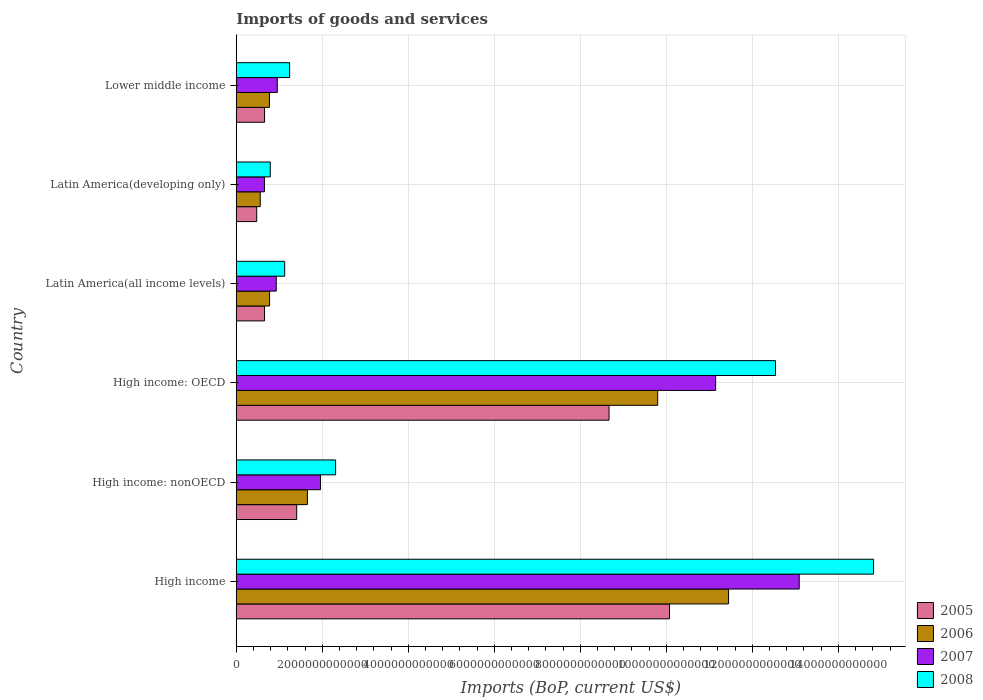How many different coloured bars are there?
Provide a succinct answer. 4. How many groups of bars are there?
Give a very brief answer. 6. What is the label of the 1st group of bars from the top?
Offer a terse response. Lower middle income. In how many cases, is the number of bars for a given country not equal to the number of legend labels?
Offer a terse response. 0. What is the amount spent on imports in 2005 in Lower middle income?
Your response must be concise. 6.58e+11. Across all countries, what is the maximum amount spent on imports in 2007?
Keep it short and to the point. 1.31e+13. Across all countries, what is the minimum amount spent on imports in 2006?
Make the answer very short. 5.57e+11. In which country was the amount spent on imports in 2005 minimum?
Offer a terse response. Latin America(developing only). What is the total amount spent on imports in 2008 in the graph?
Make the answer very short. 3.28e+13. What is the difference between the amount spent on imports in 2005 in High income: nonOECD and that in Lower middle income?
Your answer should be very brief. 7.47e+11. What is the difference between the amount spent on imports in 2005 in Latin America(all income levels) and the amount spent on imports in 2006 in Latin America(developing only)?
Keep it short and to the point. 9.99e+1. What is the average amount spent on imports in 2007 per country?
Give a very brief answer. 4.79e+12. What is the difference between the amount spent on imports in 2007 and amount spent on imports in 2008 in Latin America(all income levels)?
Keep it short and to the point. -1.96e+11. What is the ratio of the amount spent on imports in 2007 in High income: OECD to that in Latin America(developing only)?
Your response must be concise. 17.01. Is the amount spent on imports in 2007 in High income: OECD less than that in High income: nonOECD?
Your answer should be very brief. No. Is the difference between the amount spent on imports in 2007 in High income: nonOECD and Latin America(all income levels) greater than the difference between the amount spent on imports in 2008 in High income: nonOECD and Latin America(all income levels)?
Provide a succinct answer. No. What is the difference between the highest and the second highest amount spent on imports in 2007?
Offer a very short reply. 1.94e+12. What is the difference between the highest and the lowest amount spent on imports in 2006?
Give a very brief answer. 1.09e+13. In how many countries, is the amount spent on imports in 2007 greater than the average amount spent on imports in 2007 taken over all countries?
Give a very brief answer. 2. Is it the case that in every country, the sum of the amount spent on imports in 2006 and amount spent on imports in 2008 is greater than the sum of amount spent on imports in 2007 and amount spent on imports in 2005?
Give a very brief answer. No. What does the 3rd bar from the bottom in Latin America(developing only) represents?
Make the answer very short. 2007. What is the difference between two consecutive major ticks on the X-axis?
Your answer should be compact. 2.00e+12. Does the graph contain any zero values?
Provide a short and direct response. No. Where does the legend appear in the graph?
Ensure brevity in your answer.  Bottom right. How are the legend labels stacked?
Ensure brevity in your answer.  Vertical. What is the title of the graph?
Your response must be concise. Imports of goods and services. Does "1970" appear as one of the legend labels in the graph?
Your response must be concise. No. What is the label or title of the X-axis?
Ensure brevity in your answer.  Imports (BoP, current US$). What is the Imports (BoP, current US$) of 2005 in High income?
Offer a terse response. 1.01e+13. What is the Imports (BoP, current US$) of 2006 in High income?
Give a very brief answer. 1.14e+13. What is the Imports (BoP, current US$) in 2007 in High income?
Provide a succinct answer. 1.31e+13. What is the Imports (BoP, current US$) in 2008 in High income?
Your response must be concise. 1.48e+13. What is the Imports (BoP, current US$) of 2005 in High income: nonOECD?
Ensure brevity in your answer.  1.41e+12. What is the Imports (BoP, current US$) in 2006 in High income: nonOECD?
Give a very brief answer. 1.65e+12. What is the Imports (BoP, current US$) in 2007 in High income: nonOECD?
Ensure brevity in your answer.  1.96e+12. What is the Imports (BoP, current US$) in 2008 in High income: nonOECD?
Your answer should be compact. 2.31e+12. What is the Imports (BoP, current US$) in 2005 in High income: OECD?
Keep it short and to the point. 8.67e+12. What is the Imports (BoP, current US$) in 2006 in High income: OECD?
Ensure brevity in your answer.  9.80e+12. What is the Imports (BoP, current US$) of 2007 in High income: OECD?
Your response must be concise. 1.11e+13. What is the Imports (BoP, current US$) in 2008 in High income: OECD?
Your response must be concise. 1.25e+13. What is the Imports (BoP, current US$) in 2005 in Latin America(all income levels)?
Ensure brevity in your answer.  6.57e+11. What is the Imports (BoP, current US$) in 2006 in Latin America(all income levels)?
Ensure brevity in your answer.  7.75e+11. What is the Imports (BoP, current US$) in 2007 in Latin America(all income levels)?
Keep it short and to the point. 9.30e+11. What is the Imports (BoP, current US$) in 2008 in Latin America(all income levels)?
Provide a succinct answer. 1.13e+12. What is the Imports (BoP, current US$) of 2005 in Latin America(developing only)?
Your answer should be very brief. 4.75e+11. What is the Imports (BoP, current US$) in 2006 in Latin America(developing only)?
Offer a very short reply. 5.57e+11. What is the Imports (BoP, current US$) in 2007 in Latin America(developing only)?
Your answer should be very brief. 6.55e+11. What is the Imports (BoP, current US$) of 2008 in Latin America(developing only)?
Ensure brevity in your answer.  7.91e+11. What is the Imports (BoP, current US$) in 2005 in Lower middle income?
Give a very brief answer. 6.58e+11. What is the Imports (BoP, current US$) in 2006 in Lower middle income?
Provide a succinct answer. 7.71e+11. What is the Imports (BoP, current US$) in 2007 in Lower middle income?
Your answer should be very brief. 9.53e+11. What is the Imports (BoP, current US$) in 2008 in Lower middle income?
Give a very brief answer. 1.24e+12. Across all countries, what is the maximum Imports (BoP, current US$) of 2005?
Your answer should be compact. 1.01e+13. Across all countries, what is the maximum Imports (BoP, current US$) of 2006?
Your answer should be compact. 1.14e+13. Across all countries, what is the maximum Imports (BoP, current US$) of 2007?
Offer a very short reply. 1.31e+13. Across all countries, what is the maximum Imports (BoP, current US$) in 2008?
Provide a succinct answer. 1.48e+13. Across all countries, what is the minimum Imports (BoP, current US$) of 2005?
Offer a very short reply. 4.75e+11. Across all countries, what is the minimum Imports (BoP, current US$) of 2006?
Offer a terse response. 5.57e+11. Across all countries, what is the minimum Imports (BoP, current US$) in 2007?
Ensure brevity in your answer.  6.55e+11. Across all countries, what is the minimum Imports (BoP, current US$) of 2008?
Offer a terse response. 7.91e+11. What is the total Imports (BoP, current US$) in 2005 in the graph?
Your answer should be very brief. 2.19e+13. What is the total Imports (BoP, current US$) of 2006 in the graph?
Make the answer very short. 2.50e+13. What is the total Imports (BoP, current US$) in 2007 in the graph?
Offer a very short reply. 2.87e+13. What is the total Imports (BoP, current US$) in 2008 in the graph?
Your answer should be very brief. 3.28e+13. What is the difference between the Imports (BoP, current US$) of 2005 in High income and that in High income: nonOECD?
Provide a short and direct response. 8.67e+12. What is the difference between the Imports (BoP, current US$) of 2006 in High income and that in High income: nonOECD?
Your response must be concise. 9.79e+12. What is the difference between the Imports (BoP, current US$) in 2007 in High income and that in High income: nonOECD?
Offer a terse response. 1.11e+13. What is the difference between the Imports (BoP, current US$) in 2008 in High income and that in High income: nonOECD?
Make the answer very short. 1.25e+13. What is the difference between the Imports (BoP, current US$) in 2005 in High income and that in High income: OECD?
Make the answer very short. 1.41e+12. What is the difference between the Imports (BoP, current US$) of 2006 in High income and that in High income: OECD?
Your answer should be very brief. 1.65e+12. What is the difference between the Imports (BoP, current US$) of 2007 in High income and that in High income: OECD?
Keep it short and to the point. 1.94e+12. What is the difference between the Imports (BoP, current US$) of 2008 in High income and that in High income: OECD?
Make the answer very short. 2.28e+12. What is the difference between the Imports (BoP, current US$) of 2005 in High income and that in Latin America(all income levels)?
Provide a short and direct response. 9.42e+12. What is the difference between the Imports (BoP, current US$) of 2006 in High income and that in Latin America(all income levels)?
Make the answer very short. 1.07e+13. What is the difference between the Imports (BoP, current US$) of 2007 in High income and that in Latin America(all income levels)?
Provide a succinct answer. 1.22e+13. What is the difference between the Imports (BoP, current US$) in 2008 in High income and that in Latin America(all income levels)?
Make the answer very short. 1.37e+13. What is the difference between the Imports (BoP, current US$) in 2005 in High income and that in Latin America(developing only)?
Provide a succinct answer. 9.60e+12. What is the difference between the Imports (BoP, current US$) in 2006 in High income and that in Latin America(developing only)?
Keep it short and to the point. 1.09e+13. What is the difference between the Imports (BoP, current US$) of 2007 in High income and that in Latin America(developing only)?
Offer a terse response. 1.24e+13. What is the difference between the Imports (BoP, current US$) of 2008 in High income and that in Latin America(developing only)?
Give a very brief answer. 1.40e+13. What is the difference between the Imports (BoP, current US$) of 2005 in High income and that in Lower middle income?
Make the answer very short. 9.42e+12. What is the difference between the Imports (BoP, current US$) in 2006 in High income and that in Lower middle income?
Make the answer very short. 1.07e+13. What is the difference between the Imports (BoP, current US$) in 2007 in High income and that in Lower middle income?
Offer a terse response. 1.21e+13. What is the difference between the Imports (BoP, current US$) of 2008 in High income and that in Lower middle income?
Provide a short and direct response. 1.36e+13. What is the difference between the Imports (BoP, current US$) of 2005 in High income: nonOECD and that in High income: OECD?
Your response must be concise. -7.26e+12. What is the difference between the Imports (BoP, current US$) of 2006 in High income: nonOECD and that in High income: OECD?
Your answer should be very brief. -8.14e+12. What is the difference between the Imports (BoP, current US$) of 2007 in High income: nonOECD and that in High income: OECD?
Provide a short and direct response. -9.19e+12. What is the difference between the Imports (BoP, current US$) of 2008 in High income: nonOECD and that in High income: OECD?
Keep it short and to the point. -1.02e+13. What is the difference between the Imports (BoP, current US$) in 2005 in High income: nonOECD and that in Latin America(all income levels)?
Provide a succinct answer. 7.48e+11. What is the difference between the Imports (BoP, current US$) of 2006 in High income: nonOECD and that in Latin America(all income levels)?
Provide a short and direct response. 8.79e+11. What is the difference between the Imports (BoP, current US$) of 2007 in High income: nonOECD and that in Latin America(all income levels)?
Ensure brevity in your answer.  1.03e+12. What is the difference between the Imports (BoP, current US$) of 2008 in High income: nonOECD and that in Latin America(all income levels)?
Provide a short and direct response. 1.18e+12. What is the difference between the Imports (BoP, current US$) of 2005 in High income: nonOECD and that in Latin America(developing only)?
Your answer should be very brief. 9.30e+11. What is the difference between the Imports (BoP, current US$) of 2006 in High income: nonOECD and that in Latin America(developing only)?
Your answer should be very brief. 1.10e+12. What is the difference between the Imports (BoP, current US$) of 2007 in High income: nonOECD and that in Latin America(developing only)?
Your answer should be compact. 1.30e+12. What is the difference between the Imports (BoP, current US$) in 2008 in High income: nonOECD and that in Latin America(developing only)?
Your answer should be compact. 1.52e+12. What is the difference between the Imports (BoP, current US$) of 2005 in High income: nonOECD and that in Lower middle income?
Your answer should be very brief. 7.47e+11. What is the difference between the Imports (BoP, current US$) of 2006 in High income: nonOECD and that in Lower middle income?
Keep it short and to the point. 8.83e+11. What is the difference between the Imports (BoP, current US$) in 2007 in High income: nonOECD and that in Lower middle income?
Provide a succinct answer. 1.01e+12. What is the difference between the Imports (BoP, current US$) in 2008 in High income: nonOECD and that in Lower middle income?
Ensure brevity in your answer.  1.07e+12. What is the difference between the Imports (BoP, current US$) of 2005 in High income: OECD and that in Latin America(all income levels)?
Your answer should be very brief. 8.01e+12. What is the difference between the Imports (BoP, current US$) of 2006 in High income: OECD and that in Latin America(all income levels)?
Your response must be concise. 9.02e+12. What is the difference between the Imports (BoP, current US$) of 2007 in High income: OECD and that in Latin America(all income levels)?
Your response must be concise. 1.02e+13. What is the difference between the Imports (BoP, current US$) of 2008 in High income: OECD and that in Latin America(all income levels)?
Provide a short and direct response. 1.14e+13. What is the difference between the Imports (BoP, current US$) in 2005 in High income: OECD and that in Latin America(developing only)?
Your answer should be very brief. 8.19e+12. What is the difference between the Imports (BoP, current US$) in 2006 in High income: OECD and that in Latin America(developing only)?
Keep it short and to the point. 9.24e+12. What is the difference between the Imports (BoP, current US$) in 2007 in High income: OECD and that in Latin America(developing only)?
Provide a succinct answer. 1.05e+13. What is the difference between the Imports (BoP, current US$) of 2008 in High income: OECD and that in Latin America(developing only)?
Offer a terse response. 1.17e+13. What is the difference between the Imports (BoP, current US$) in 2005 in High income: OECD and that in Lower middle income?
Offer a very short reply. 8.01e+12. What is the difference between the Imports (BoP, current US$) in 2006 in High income: OECD and that in Lower middle income?
Your response must be concise. 9.03e+12. What is the difference between the Imports (BoP, current US$) in 2007 in High income: OECD and that in Lower middle income?
Your response must be concise. 1.02e+13. What is the difference between the Imports (BoP, current US$) in 2008 in High income: OECD and that in Lower middle income?
Your answer should be very brief. 1.13e+13. What is the difference between the Imports (BoP, current US$) of 2005 in Latin America(all income levels) and that in Latin America(developing only)?
Give a very brief answer. 1.82e+11. What is the difference between the Imports (BoP, current US$) of 2006 in Latin America(all income levels) and that in Latin America(developing only)?
Give a very brief answer. 2.18e+11. What is the difference between the Imports (BoP, current US$) in 2007 in Latin America(all income levels) and that in Latin America(developing only)?
Ensure brevity in your answer.  2.75e+11. What is the difference between the Imports (BoP, current US$) of 2008 in Latin America(all income levels) and that in Latin America(developing only)?
Keep it short and to the point. 3.35e+11. What is the difference between the Imports (BoP, current US$) in 2005 in Latin America(all income levels) and that in Lower middle income?
Provide a succinct answer. -6.55e+08. What is the difference between the Imports (BoP, current US$) of 2006 in Latin America(all income levels) and that in Lower middle income?
Your answer should be very brief. 4.18e+09. What is the difference between the Imports (BoP, current US$) of 2007 in Latin America(all income levels) and that in Lower middle income?
Ensure brevity in your answer.  -2.36e+1. What is the difference between the Imports (BoP, current US$) in 2008 in Latin America(all income levels) and that in Lower middle income?
Offer a very short reply. -1.15e+11. What is the difference between the Imports (BoP, current US$) of 2005 in Latin America(developing only) and that in Lower middle income?
Make the answer very short. -1.83e+11. What is the difference between the Imports (BoP, current US$) of 2006 in Latin America(developing only) and that in Lower middle income?
Keep it short and to the point. -2.14e+11. What is the difference between the Imports (BoP, current US$) in 2007 in Latin America(developing only) and that in Lower middle income?
Your answer should be very brief. -2.98e+11. What is the difference between the Imports (BoP, current US$) of 2008 in Latin America(developing only) and that in Lower middle income?
Keep it short and to the point. -4.51e+11. What is the difference between the Imports (BoP, current US$) of 2005 in High income and the Imports (BoP, current US$) of 2006 in High income: nonOECD?
Keep it short and to the point. 8.42e+12. What is the difference between the Imports (BoP, current US$) in 2005 in High income and the Imports (BoP, current US$) in 2007 in High income: nonOECD?
Make the answer very short. 8.11e+12. What is the difference between the Imports (BoP, current US$) in 2005 in High income and the Imports (BoP, current US$) in 2008 in High income: nonOECD?
Your answer should be very brief. 7.76e+12. What is the difference between the Imports (BoP, current US$) of 2006 in High income and the Imports (BoP, current US$) of 2007 in High income: nonOECD?
Offer a very short reply. 9.49e+12. What is the difference between the Imports (BoP, current US$) in 2006 in High income and the Imports (BoP, current US$) in 2008 in High income: nonOECD?
Your response must be concise. 9.14e+12. What is the difference between the Imports (BoP, current US$) of 2007 in High income and the Imports (BoP, current US$) of 2008 in High income: nonOECD?
Provide a succinct answer. 1.08e+13. What is the difference between the Imports (BoP, current US$) in 2005 in High income and the Imports (BoP, current US$) in 2006 in High income: OECD?
Keep it short and to the point. 2.75e+11. What is the difference between the Imports (BoP, current US$) of 2005 in High income and the Imports (BoP, current US$) of 2007 in High income: OECD?
Offer a very short reply. -1.07e+12. What is the difference between the Imports (BoP, current US$) of 2005 in High income and the Imports (BoP, current US$) of 2008 in High income: OECD?
Give a very brief answer. -2.46e+12. What is the difference between the Imports (BoP, current US$) in 2006 in High income and the Imports (BoP, current US$) in 2007 in High income: OECD?
Provide a succinct answer. 3.00e+11. What is the difference between the Imports (BoP, current US$) of 2006 in High income and the Imports (BoP, current US$) of 2008 in High income: OECD?
Give a very brief answer. -1.09e+12. What is the difference between the Imports (BoP, current US$) in 2007 in High income and the Imports (BoP, current US$) in 2008 in High income: OECD?
Provide a succinct answer. 5.51e+11. What is the difference between the Imports (BoP, current US$) in 2005 in High income and the Imports (BoP, current US$) in 2006 in Latin America(all income levels)?
Your answer should be compact. 9.30e+12. What is the difference between the Imports (BoP, current US$) of 2005 in High income and the Imports (BoP, current US$) of 2007 in Latin America(all income levels)?
Provide a succinct answer. 9.14e+12. What is the difference between the Imports (BoP, current US$) in 2005 in High income and the Imports (BoP, current US$) in 2008 in Latin America(all income levels)?
Your response must be concise. 8.95e+12. What is the difference between the Imports (BoP, current US$) of 2006 in High income and the Imports (BoP, current US$) of 2007 in Latin America(all income levels)?
Provide a short and direct response. 1.05e+13. What is the difference between the Imports (BoP, current US$) of 2006 in High income and the Imports (BoP, current US$) of 2008 in Latin America(all income levels)?
Offer a terse response. 1.03e+13. What is the difference between the Imports (BoP, current US$) of 2007 in High income and the Imports (BoP, current US$) of 2008 in Latin America(all income levels)?
Keep it short and to the point. 1.20e+13. What is the difference between the Imports (BoP, current US$) of 2005 in High income and the Imports (BoP, current US$) of 2006 in Latin America(developing only)?
Keep it short and to the point. 9.52e+12. What is the difference between the Imports (BoP, current US$) in 2005 in High income and the Imports (BoP, current US$) in 2007 in Latin America(developing only)?
Provide a short and direct response. 9.42e+12. What is the difference between the Imports (BoP, current US$) in 2005 in High income and the Imports (BoP, current US$) in 2008 in Latin America(developing only)?
Ensure brevity in your answer.  9.28e+12. What is the difference between the Imports (BoP, current US$) of 2006 in High income and the Imports (BoP, current US$) of 2007 in Latin America(developing only)?
Your response must be concise. 1.08e+13. What is the difference between the Imports (BoP, current US$) in 2006 in High income and the Imports (BoP, current US$) in 2008 in Latin America(developing only)?
Make the answer very short. 1.07e+13. What is the difference between the Imports (BoP, current US$) in 2007 in High income and the Imports (BoP, current US$) in 2008 in Latin America(developing only)?
Make the answer very short. 1.23e+13. What is the difference between the Imports (BoP, current US$) of 2005 in High income and the Imports (BoP, current US$) of 2006 in Lower middle income?
Keep it short and to the point. 9.30e+12. What is the difference between the Imports (BoP, current US$) of 2005 in High income and the Imports (BoP, current US$) of 2007 in Lower middle income?
Your answer should be very brief. 9.12e+12. What is the difference between the Imports (BoP, current US$) in 2005 in High income and the Imports (BoP, current US$) in 2008 in Lower middle income?
Your answer should be compact. 8.83e+12. What is the difference between the Imports (BoP, current US$) in 2006 in High income and the Imports (BoP, current US$) in 2007 in Lower middle income?
Give a very brief answer. 1.05e+13. What is the difference between the Imports (BoP, current US$) in 2006 in High income and the Imports (BoP, current US$) in 2008 in Lower middle income?
Offer a very short reply. 1.02e+13. What is the difference between the Imports (BoP, current US$) of 2007 in High income and the Imports (BoP, current US$) of 2008 in Lower middle income?
Provide a short and direct response. 1.18e+13. What is the difference between the Imports (BoP, current US$) in 2005 in High income: nonOECD and the Imports (BoP, current US$) in 2006 in High income: OECD?
Make the answer very short. -8.39e+12. What is the difference between the Imports (BoP, current US$) in 2005 in High income: nonOECD and the Imports (BoP, current US$) in 2007 in High income: OECD?
Your answer should be compact. -9.74e+12. What is the difference between the Imports (BoP, current US$) of 2005 in High income: nonOECD and the Imports (BoP, current US$) of 2008 in High income: OECD?
Keep it short and to the point. -1.11e+13. What is the difference between the Imports (BoP, current US$) in 2006 in High income: nonOECD and the Imports (BoP, current US$) in 2007 in High income: OECD?
Keep it short and to the point. -9.49e+12. What is the difference between the Imports (BoP, current US$) in 2006 in High income: nonOECD and the Imports (BoP, current US$) in 2008 in High income: OECD?
Offer a terse response. -1.09e+13. What is the difference between the Imports (BoP, current US$) in 2007 in High income: nonOECD and the Imports (BoP, current US$) in 2008 in High income: OECD?
Ensure brevity in your answer.  -1.06e+13. What is the difference between the Imports (BoP, current US$) of 2005 in High income: nonOECD and the Imports (BoP, current US$) of 2006 in Latin America(all income levels)?
Your response must be concise. 6.30e+11. What is the difference between the Imports (BoP, current US$) in 2005 in High income: nonOECD and the Imports (BoP, current US$) in 2007 in Latin America(all income levels)?
Provide a succinct answer. 4.76e+11. What is the difference between the Imports (BoP, current US$) of 2005 in High income: nonOECD and the Imports (BoP, current US$) of 2008 in Latin America(all income levels)?
Your response must be concise. 2.79e+11. What is the difference between the Imports (BoP, current US$) in 2006 in High income: nonOECD and the Imports (BoP, current US$) in 2007 in Latin America(all income levels)?
Provide a succinct answer. 7.25e+11. What is the difference between the Imports (BoP, current US$) in 2006 in High income: nonOECD and the Imports (BoP, current US$) in 2008 in Latin America(all income levels)?
Provide a succinct answer. 5.28e+11. What is the difference between the Imports (BoP, current US$) in 2007 in High income: nonOECD and the Imports (BoP, current US$) in 2008 in Latin America(all income levels)?
Make the answer very short. 8.33e+11. What is the difference between the Imports (BoP, current US$) of 2005 in High income: nonOECD and the Imports (BoP, current US$) of 2006 in Latin America(developing only)?
Your answer should be compact. 8.48e+11. What is the difference between the Imports (BoP, current US$) of 2005 in High income: nonOECD and the Imports (BoP, current US$) of 2007 in Latin America(developing only)?
Provide a succinct answer. 7.50e+11. What is the difference between the Imports (BoP, current US$) of 2005 in High income: nonOECD and the Imports (BoP, current US$) of 2008 in Latin America(developing only)?
Make the answer very short. 6.15e+11. What is the difference between the Imports (BoP, current US$) in 2006 in High income: nonOECD and the Imports (BoP, current US$) in 2007 in Latin America(developing only)?
Your answer should be very brief. 9.99e+11. What is the difference between the Imports (BoP, current US$) of 2006 in High income: nonOECD and the Imports (BoP, current US$) of 2008 in Latin America(developing only)?
Your answer should be compact. 8.64e+11. What is the difference between the Imports (BoP, current US$) of 2007 in High income: nonOECD and the Imports (BoP, current US$) of 2008 in Latin America(developing only)?
Ensure brevity in your answer.  1.17e+12. What is the difference between the Imports (BoP, current US$) of 2005 in High income: nonOECD and the Imports (BoP, current US$) of 2006 in Lower middle income?
Your answer should be compact. 6.34e+11. What is the difference between the Imports (BoP, current US$) in 2005 in High income: nonOECD and the Imports (BoP, current US$) in 2007 in Lower middle income?
Your response must be concise. 4.52e+11. What is the difference between the Imports (BoP, current US$) of 2005 in High income: nonOECD and the Imports (BoP, current US$) of 2008 in Lower middle income?
Keep it short and to the point. 1.64e+11. What is the difference between the Imports (BoP, current US$) in 2006 in High income: nonOECD and the Imports (BoP, current US$) in 2007 in Lower middle income?
Give a very brief answer. 7.01e+11. What is the difference between the Imports (BoP, current US$) in 2006 in High income: nonOECD and the Imports (BoP, current US$) in 2008 in Lower middle income?
Your answer should be very brief. 4.13e+11. What is the difference between the Imports (BoP, current US$) of 2007 in High income: nonOECD and the Imports (BoP, current US$) of 2008 in Lower middle income?
Provide a short and direct response. 7.17e+11. What is the difference between the Imports (BoP, current US$) of 2005 in High income: OECD and the Imports (BoP, current US$) of 2006 in Latin America(all income levels)?
Give a very brief answer. 7.89e+12. What is the difference between the Imports (BoP, current US$) in 2005 in High income: OECD and the Imports (BoP, current US$) in 2007 in Latin America(all income levels)?
Keep it short and to the point. 7.74e+12. What is the difference between the Imports (BoP, current US$) in 2005 in High income: OECD and the Imports (BoP, current US$) in 2008 in Latin America(all income levels)?
Provide a succinct answer. 7.54e+12. What is the difference between the Imports (BoP, current US$) in 2006 in High income: OECD and the Imports (BoP, current US$) in 2007 in Latin America(all income levels)?
Your response must be concise. 8.87e+12. What is the difference between the Imports (BoP, current US$) of 2006 in High income: OECD and the Imports (BoP, current US$) of 2008 in Latin America(all income levels)?
Ensure brevity in your answer.  8.67e+12. What is the difference between the Imports (BoP, current US$) of 2007 in High income: OECD and the Imports (BoP, current US$) of 2008 in Latin America(all income levels)?
Your response must be concise. 1.00e+13. What is the difference between the Imports (BoP, current US$) in 2005 in High income: OECD and the Imports (BoP, current US$) in 2006 in Latin America(developing only)?
Your answer should be compact. 8.11e+12. What is the difference between the Imports (BoP, current US$) of 2005 in High income: OECD and the Imports (BoP, current US$) of 2007 in Latin America(developing only)?
Your response must be concise. 8.01e+12. What is the difference between the Imports (BoP, current US$) in 2005 in High income: OECD and the Imports (BoP, current US$) in 2008 in Latin America(developing only)?
Ensure brevity in your answer.  7.88e+12. What is the difference between the Imports (BoP, current US$) in 2006 in High income: OECD and the Imports (BoP, current US$) in 2007 in Latin America(developing only)?
Make the answer very short. 9.14e+12. What is the difference between the Imports (BoP, current US$) of 2006 in High income: OECD and the Imports (BoP, current US$) of 2008 in Latin America(developing only)?
Provide a succinct answer. 9.01e+12. What is the difference between the Imports (BoP, current US$) in 2007 in High income: OECD and the Imports (BoP, current US$) in 2008 in Latin America(developing only)?
Your response must be concise. 1.04e+13. What is the difference between the Imports (BoP, current US$) in 2005 in High income: OECD and the Imports (BoP, current US$) in 2006 in Lower middle income?
Offer a terse response. 7.90e+12. What is the difference between the Imports (BoP, current US$) of 2005 in High income: OECD and the Imports (BoP, current US$) of 2007 in Lower middle income?
Your response must be concise. 7.71e+12. What is the difference between the Imports (BoP, current US$) of 2005 in High income: OECD and the Imports (BoP, current US$) of 2008 in Lower middle income?
Offer a terse response. 7.43e+12. What is the difference between the Imports (BoP, current US$) in 2006 in High income: OECD and the Imports (BoP, current US$) in 2007 in Lower middle income?
Provide a short and direct response. 8.85e+12. What is the difference between the Imports (BoP, current US$) in 2006 in High income: OECD and the Imports (BoP, current US$) in 2008 in Lower middle income?
Ensure brevity in your answer.  8.56e+12. What is the difference between the Imports (BoP, current US$) in 2007 in High income: OECD and the Imports (BoP, current US$) in 2008 in Lower middle income?
Your answer should be very brief. 9.91e+12. What is the difference between the Imports (BoP, current US$) in 2005 in Latin America(all income levels) and the Imports (BoP, current US$) in 2006 in Latin America(developing only)?
Your answer should be very brief. 9.99e+1. What is the difference between the Imports (BoP, current US$) in 2005 in Latin America(all income levels) and the Imports (BoP, current US$) in 2007 in Latin America(developing only)?
Your response must be concise. 2.04e+09. What is the difference between the Imports (BoP, current US$) in 2005 in Latin America(all income levels) and the Imports (BoP, current US$) in 2008 in Latin America(developing only)?
Make the answer very short. -1.33e+11. What is the difference between the Imports (BoP, current US$) of 2006 in Latin America(all income levels) and the Imports (BoP, current US$) of 2007 in Latin America(developing only)?
Provide a short and direct response. 1.20e+11. What is the difference between the Imports (BoP, current US$) of 2006 in Latin America(all income levels) and the Imports (BoP, current US$) of 2008 in Latin America(developing only)?
Make the answer very short. -1.55e+1. What is the difference between the Imports (BoP, current US$) of 2007 in Latin America(all income levels) and the Imports (BoP, current US$) of 2008 in Latin America(developing only)?
Offer a terse response. 1.39e+11. What is the difference between the Imports (BoP, current US$) of 2005 in Latin America(all income levels) and the Imports (BoP, current US$) of 2006 in Lower middle income?
Keep it short and to the point. -1.14e+11. What is the difference between the Imports (BoP, current US$) of 2005 in Latin America(all income levels) and the Imports (BoP, current US$) of 2007 in Lower middle income?
Keep it short and to the point. -2.96e+11. What is the difference between the Imports (BoP, current US$) in 2005 in Latin America(all income levels) and the Imports (BoP, current US$) in 2008 in Lower middle income?
Your answer should be compact. -5.84e+11. What is the difference between the Imports (BoP, current US$) of 2006 in Latin America(all income levels) and the Imports (BoP, current US$) of 2007 in Lower middle income?
Make the answer very short. -1.78e+11. What is the difference between the Imports (BoP, current US$) in 2006 in Latin America(all income levels) and the Imports (BoP, current US$) in 2008 in Lower middle income?
Make the answer very short. -4.66e+11. What is the difference between the Imports (BoP, current US$) in 2007 in Latin America(all income levels) and the Imports (BoP, current US$) in 2008 in Lower middle income?
Provide a short and direct response. -3.12e+11. What is the difference between the Imports (BoP, current US$) in 2005 in Latin America(developing only) and the Imports (BoP, current US$) in 2006 in Lower middle income?
Your response must be concise. -2.96e+11. What is the difference between the Imports (BoP, current US$) of 2005 in Latin America(developing only) and the Imports (BoP, current US$) of 2007 in Lower middle income?
Give a very brief answer. -4.78e+11. What is the difference between the Imports (BoP, current US$) of 2005 in Latin America(developing only) and the Imports (BoP, current US$) of 2008 in Lower middle income?
Ensure brevity in your answer.  -7.66e+11. What is the difference between the Imports (BoP, current US$) of 2006 in Latin America(developing only) and the Imports (BoP, current US$) of 2007 in Lower middle income?
Keep it short and to the point. -3.96e+11. What is the difference between the Imports (BoP, current US$) in 2006 in Latin America(developing only) and the Imports (BoP, current US$) in 2008 in Lower middle income?
Your response must be concise. -6.84e+11. What is the difference between the Imports (BoP, current US$) of 2007 in Latin America(developing only) and the Imports (BoP, current US$) of 2008 in Lower middle income?
Offer a terse response. -5.86e+11. What is the average Imports (BoP, current US$) in 2005 per country?
Your response must be concise. 3.66e+12. What is the average Imports (BoP, current US$) in 2006 per country?
Give a very brief answer. 4.17e+12. What is the average Imports (BoP, current US$) of 2007 per country?
Provide a succinct answer. 4.79e+12. What is the average Imports (BoP, current US$) in 2008 per country?
Make the answer very short. 5.47e+12. What is the difference between the Imports (BoP, current US$) of 2005 and Imports (BoP, current US$) of 2006 in High income?
Your answer should be compact. -1.37e+12. What is the difference between the Imports (BoP, current US$) of 2005 and Imports (BoP, current US$) of 2007 in High income?
Ensure brevity in your answer.  -3.02e+12. What is the difference between the Imports (BoP, current US$) of 2005 and Imports (BoP, current US$) of 2008 in High income?
Provide a short and direct response. -4.74e+12. What is the difference between the Imports (BoP, current US$) of 2006 and Imports (BoP, current US$) of 2007 in High income?
Make the answer very short. -1.64e+12. What is the difference between the Imports (BoP, current US$) in 2006 and Imports (BoP, current US$) in 2008 in High income?
Keep it short and to the point. -3.37e+12. What is the difference between the Imports (BoP, current US$) in 2007 and Imports (BoP, current US$) in 2008 in High income?
Make the answer very short. -1.73e+12. What is the difference between the Imports (BoP, current US$) in 2005 and Imports (BoP, current US$) in 2006 in High income: nonOECD?
Provide a succinct answer. -2.49e+11. What is the difference between the Imports (BoP, current US$) in 2005 and Imports (BoP, current US$) in 2007 in High income: nonOECD?
Make the answer very short. -5.53e+11. What is the difference between the Imports (BoP, current US$) in 2005 and Imports (BoP, current US$) in 2008 in High income: nonOECD?
Provide a short and direct response. -9.05e+11. What is the difference between the Imports (BoP, current US$) of 2006 and Imports (BoP, current US$) of 2007 in High income: nonOECD?
Offer a terse response. -3.04e+11. What is the difference between the Imports (BoP, current US$) of 2006 and Imports (BoP, current US$) of 2008 in High income: nonOECD?
Your answer should be compact. -6.56e+11. What is the difference between the Imports (BoP, current US$) of 2007 and Imports (BoP, current US$) of 2008 in High income: nonOECD?
Offer a terse response. -3.51e+11. What is the difference between the Imports (BoP, current US$) of 2005 and Imports (BoP, current US$) of 2006 in High income: OECD?
Your answer should be very brief. -1.13e+12. What is the difference between the Imports (BoP, current US$) of 2005 and Imports (BoP, current US$) of 2007 in High income: OECD?
Your answer should be compact. -2.48e+12. What is the difference between the Imports (BoP, current US$) of 2005 and Imports (BoP, current US$) of 2008 in High income: OECD?
Offer a terse response. -3.87e+12. What is the difference between the Imports (BoP, current US$) in 2006 and Imports (BoP, current US$) in 2007 in High income: OECD?
Offer a very short reply. -1.35e+12. What is the difference between the Imports (BoP, current US$) in 2006 and Imports (BoP, current US$) in 2008 in High income: OECD?
Your answer should be compact. -2.74e+12. What is the difference between the Imports (BoP, current US$) in 2007 and Imports (BoP, current US$) in 2008 in High income: OECD?
Your answer should be very brief. -1.39e+12. What is the difference between the Imports (BoP, current US$) in 2005 and Imports (BoP, current US$) in 2006 in Latin America(all income levels)?
Your response must be concise. -1.18e+11. What is the difference between the Imports (BoP, current US$) in 2005 and Imports (BoP, current US$) in 2007 in Latin America(all income levels)?
Give a very brief answer. -2.72e+11. What is the difference between the Imports (BoP, current US$) of 2005 and Imports (BoP, current US$) of 2008 in Latin America(all income levels)?
Your answer should be very brief. -4.69e+11. What is the difference between the Imports (BoP, current US$) in 2006 and Imports (BoP, current US$) in 2007 in Latin America(all income levels)?
Your response must be concise. -1.54e+11. What is the difference between the Imports (BoP, current US$) in 2006 and Imports (BoP, current US$) in 2008 in Latin America(all income levels)?
Offer a very short reply. -3.51e+11. What is the difference between the Imports (BoP, current US$) in 2007 and Imports (BoP, current US$) in 2008 in Latin America(all income levels)?
Provide a succinct answer. -1.96e+11. What is the difference between the Imports (BoP, current US$) in 2005 and Imports (BoP, current US$) in 2006 in Latin America(developing only)?
Offer a terse response. -8.20e+1. What is the difference between the Imports (BoP, current US$) of 2005 and Imports (BoP, current US$) of 2007 in Latin America(developing only)?
Your response must be concise. -1.80e+11. What is the difference between the Imports (BoP, current US$) in 2005 and Imports (BoP, current US$) in 2008 in Latin America(developing only)?
Your answer should be compact. -3.15e+11. What is the difference between the Imports (BoP, current US$) in 2006 and Imports (BoP, current US$) in 2007 in Latin America(developing only)?
Give a very brief answer. -9.79e+1. What is the difference between the Imports (BoP, current US$) in 2006 and Imports (BoP, current US$) in 2008 in Latin America(developing only)?
Provide a succinct answer. -2.33e+11. What is the difference between the Imports (BoP, current US$) of 2007 and Imports (BoP, current US$) of 2008 in Latin America(developing only)?
Your answer should be compact. -1.36e+11. What is the difference between the Imports (BoP, current US$) in 2005 and Imports (BoP, current US$) in 2006 in Lower middle income?
Ensure brevity in your answer.  -1.13e+11. What is the difference between the Imports (BoP, current US$) of 2005 and Imports (BoP, current US$) of 2007 in Lower middle income?
Keep it short and to the point. -2.95e+11. What is the difference between the Imports (BoP, current US$) in 2005 and Imports (BoP, current US$) in 2008 in Lower middle income?
Your answer should be compact. -5.83e+11. What is the difference between the Imports (BoP, current US$) in 2006 and Imports (BoP, current US$) in 2007 in Lower middle income?
Your answer should be compact. -1.82e+11. What is the difference between the Imports (BoP, current US$) of 2006 and Imports (BoP, current US$) of 2008 in Lower middle income?
Ensure brevity in your answer.  -4.70e+11. What is the difference between the Imports (BoP, current US$) in 2007 and Imports (BoP, current US$) in 2008 in Lower middle income?
Your response must be concise. -2.88e+11. What is the ratio of the Imports (BoP, current US$) in 2005 in High income to that in High income: nonOECD?
Your response must be concise. 7.17. What is the ratio of the Imports (BoP, current US$) of 2006 in High income to that in High income: nonOECD?
Your response must be concise. 6.92. What is the ratio of the Imports (BoP, current US$) of 2007 in High income to that in High income: nonOECD?
Keep it short and to the point. 6.68. What is the ratio of the Imports (BoP, current US$) in 2008 in High income to that in High income: nonOECD?
Offer a terse response. 6.41. What is the ratio of the Imports (BoP, current US$) in 2005 in High income to that in High income: OECD?
Provide a short and direct response. 1.16. What is the ratio of the Imports (BoP, current US$) in 2006 in High income to that in High income: OECD?
Your answer should be very brief. 1.17. What is the ratio of the Imports (BoP, current US$) of 2007 in High income to that in High income: OECD?
Offer a terse response. 1.17. What is the ratio of the Imports (BoP, current US$) of 2008 in High income to that in High income: OECD?
Your answer should be very brief. 1.18. What is the ratio of the Imports (BoP, current US$) in 2005 in High income to that in Latin America(all income levels)?
Offer a very short reply. 15.33. What is the ratio of the Imports (BoP, current US$) in 2006 in High income to that in Latin America(all income levels)?
Give a very brief answer. 14.76. What is the ratio of the Imports (BoP, current US$) of 2007 in High income to that in Latin America(all income levels)?
Offer a very short reply. 14.08. What is the ratio of the Imports (BoP, current US$) of 2008 in High income to that in Latin America(all income levels)?
Offer a very short reply. 13.16. What is the ratio of the Imports (BoP, current US$) of 2005 in High income to that in Latin America(developing only)?
Ensure brevity in your answer.  21.19. What is the ratio of the Imports (BoP, current US$) of 2006 in High income to that in Latin America(developing only)?
Offer a very short reply. 20.54. What is the ratio of the Imports (BoP, current US$) in 2007 in High income to that in Latin America(developing only)?
Your answer should be very brief. 19.98. What is the ratio of the Imports (BoP, current US$) in 2008 in High income to that in Latin America(developing only)?
Provide a short and direct response. 18.74. What is the ratio of the Imports (BoP, current US$) of 2005 in High income to that in Lower middle income?
Provide a short and direct response. 15.31. What is the ratio of the Imports (BoP, current US$) of 2006 in High income to that in Lower middle income?
Provide a short and direct response. 14.84. What is the ratio of the Imports (BoP, current US$) in 2007 in High income to that in Lower middle income?
Provide a short and direct response. 13.73. What is the ratio of the Imports (BoP, current US$) in 2008 in High income to that in Lower middle income?
Your response must be concise. 11.94. What is the ratio of the Imports (BoP, current US$) in 2005 in High income: nonOECD to that in High income: OECD?
Give a very brief answer. 0.16. What is the ratio of the Imports (BoP, current US$) in 2006 in High income: nonOECD to that in High income: OECD?
Offer a very short reply. 0.17. What is the ratio of the Imports (BoP, current US$) in 2007 in High income: nonOECD to that in High income: OECD?
Your response must be concise. 0.18. What is the ratio of the Imports (BoP, current US$) of 2008 in High income: nonOECD to that in High income: OECD?
Provide a succinct answer. 0.18. What is the ratio of the Imports (BoP, current US$) in 2005 in High income: nonOECD to that in Latin America(all income levels)?
Offer a terse response. 2.14. What is the ratio of the Imports (BoP, current US$) of 2006 in High income: nonOECD to that in Latin America(all income levels)?
Your answer should be very brief. 2.13. What is the ratio of the Imports (BoP, current US$) of 2007 in High income: nonOECD to that in Latin America(all income levels)?
Provide a succinct answer. 2.11. What is the ratio of the Imports (BoP, current US$) of 2008 in High income: nonOECD to that in Latin America(all income levels)?
Your answer should be very brief. 2.05. What is the ratio of the Imports (BoP, current US$) in 2005 in High income: nonOECD to that in Latin America(developing only)?
Provide a short and direct response. 2.96. What is the ratio of the Imports (BoP, current US$) in 2006 in High income: nonOECD to that in Latin America(developing only)?
Provide a short and direct response. 2.97. What is the ratio of the Imports (BoP, current US$) in 2007 in High income: nonOECD to that in Latin America(developing only)?
Keep it short and to the point. 2.99. What is the ratio of the Imports (BoP, current US$) of 2008 in High income: nonOECD to that in Latin America(developing only)?
Keep it short and to the point. 2.92. What is the ratio of the Imports (BoP, current US$) of 2005 in High income: nonOECD to that in Lower middle income?
Your response must be concise. 2.14. What is the ratio of the Imports (BoP, current US$) in 2006 in High income: nonOECD to that in Lower middle income?
Ensure brevity in your answer.  2.15. What is the ratio of the Imports (BoP, current US$) in 2007 in High income: nonOECD to that in Lower middle income?
Provide a succinct answer. 2.05. What is the ratio of the Imports (BoP, current US$) of 2008 in High income: nonOECD to that in Lower middle income?
Ensure brevity in your answer.  1.86. What is the ratio of the Imports (BoP, current US$) of 2005 in High income: OECD to that in Latin America(all income levels)?
Offer a terse response. 13.19. What is the ratio of the Imports (BoP, current US$) of 2006 in High income: OECD to that in Latin America(all income levels)?
Ensure brevity in your answer.  12.64. What is the ratio of the Imports (BoP, current US$) in 2007 in High income: OECD to that in Latin America(all income levels)?
Offer a very short reply. 11.99. What is the ratio of the Imports (BoP, current US$) of 2008 in High income: OECD to that in Latin America(all income levels)?
Offer a terse response. 11.13. What is the ratio of the Imports (BoP, current US$) of 2005 in High income: OECD to that in Latin America(developing only)?
Provide a succinct answer. 18.23. What is the ratio of the Imports (BoP, current US$) of 2006 in High income: OECD to that in Latin America(developing only)?
Your response must be concise. 17.58. What is the ratio of the Imports (BoP, current US$) in 2007 in High income: OECD to that in Latin America(developing only)?
Ensure brevity in your answer.  17.01. What is the ratio of the Imports (BoP, current US$) of 2008 in High income: OECD to that in Latin America(developing only)?
Your response must be concise. 15.86. What is the ratio of the Imports (BoP, current US$) in 2005 in High income: OECD to that in Lower middle income?
Your response must be concise. 13.17. What is the ratio of the Imports (BoP, current US$) of 2006 in High income: OECD to that in Lower middle income?
Keep it short and to the point. 12.71. What is the ratio of the Imports (BoP, current US$) in 2007 in High income: OECD to that in Lower middle income?
Your response must be concise. 11.69. What is the ratio of the Imports (BoP, current US$) in 2005 in Latin America(all income levels) to that in Latin America(developing only)?
Your response must be concise. 1.38. What is the ratio of the Imports (BoP, current US$) in 2006 in Latin America(all income levels) to that in Latin America(developing only)?
Your response must be concise. 1.39. What is the ratio of the Imports (BoP, current US$) of 2007 in Latin America(all income levels) to that in Latin America(developing only)?
Ensure brevity in your answer.  1.42. What is the ratio of the Imports (BoP, current US$) of 2008 in Latin America(all income levels) to that in Latin America(developing only)?
Your answer should be compact. 1.42. What is the ratio of the Imports (BoP, current US$) of 2006 in Latin America(all income levels) to that in Lower middle income?
Your answer should be very brief. 1.01. What is the ratio of the Imports (BoP, current US$) of 2007 in Latin America(all income levels) to that in Lower middle income?
Offer a very short reply. 0.98. What is the ratio of the Imports (BoP, current US$) of 2008 in Latin America(all income levels) to that in Lower middle income?
Keep it short and to the point. 0.91. What is the ratio of the Imports (BoP, current US$) of 2005 in Latin America(developing only) to that in Lower middle income?
Give a very brief answer. 0.72. What is the ratio of the Imports (BoP, current US$) in 2006 in Latin America(developing only) to that in Lower middle income?
Offer a very short reply. 0.72. What is the ratio of the Imports (BoP, current US$) in 2007 in Latin America(developing only) to that in Lower middle income?
Ensure brevity in your answer.  0.69. What is the ratio of the Imports (BoP, current US$) in 2008 in Latin America(developing only) to that in Lower middle income?
Make the answer very short. 0.64. What is the difference between the highest and the second highest Imports (BoP, current US$) in 2005?
Keep it short and to the point. 1.41e+12. What is the difference between the highest and the second highest Imports (BoP, current US$) in 2006?
Your answer should be very brief. 1.65e+12. What is the difference between the highest and the second highest Imports (BoP, current US$) in 2007?
Keep it short and to the point. 1.94e+12. What is the difference between the highest and the second highest Imports (BoP, current US$) in 2008?
Your answer should be compact. 2.28e+12. What is the difference between the highest and the lowest Imports (BoP, current US$) of 2005?
Your answer should be compact. 9.60e+12. What is the difference between the highest and the lowest Imports (BoP, current US$) of 2006?
Provide a succinct answer. 1.09e+13. What is the difference between the highest and the lowest Imports (BoP, current US$) in 2007?
Ensure brevity in your answer.  1.24e+13. What is the difference between the highest and the lowest Imports (BoP, current US$) in 2008?
Keep it short and to the point. 1.40e+13. 